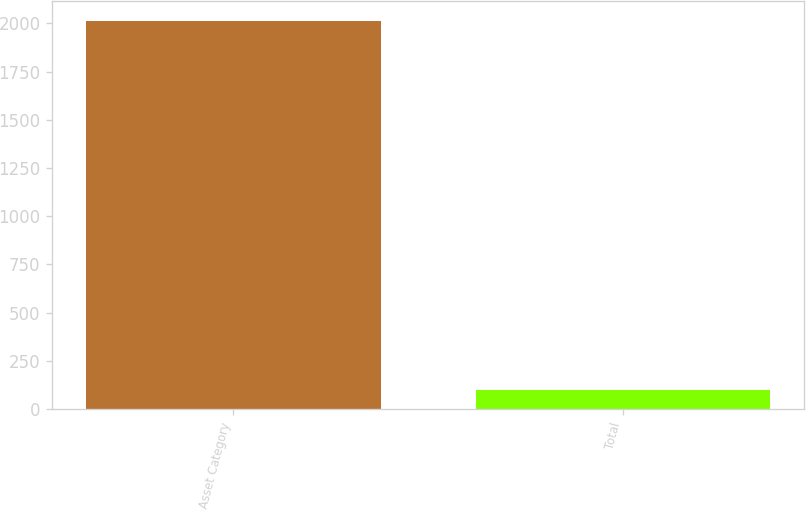Convert chart. <chart><loc_0><loc_0><loc_500><loc_500><bar_chart><fcel>Asset Category<fcel>Total<nl><fcel>2015<fcel>100<nl></chart> 